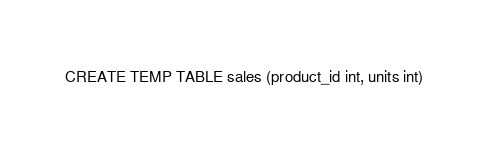<code> <loc_0><loc_0><loc_500><loc_500><_SQL_>CREATE TEMP TABLE sales (product_id int, units int)
</code> 